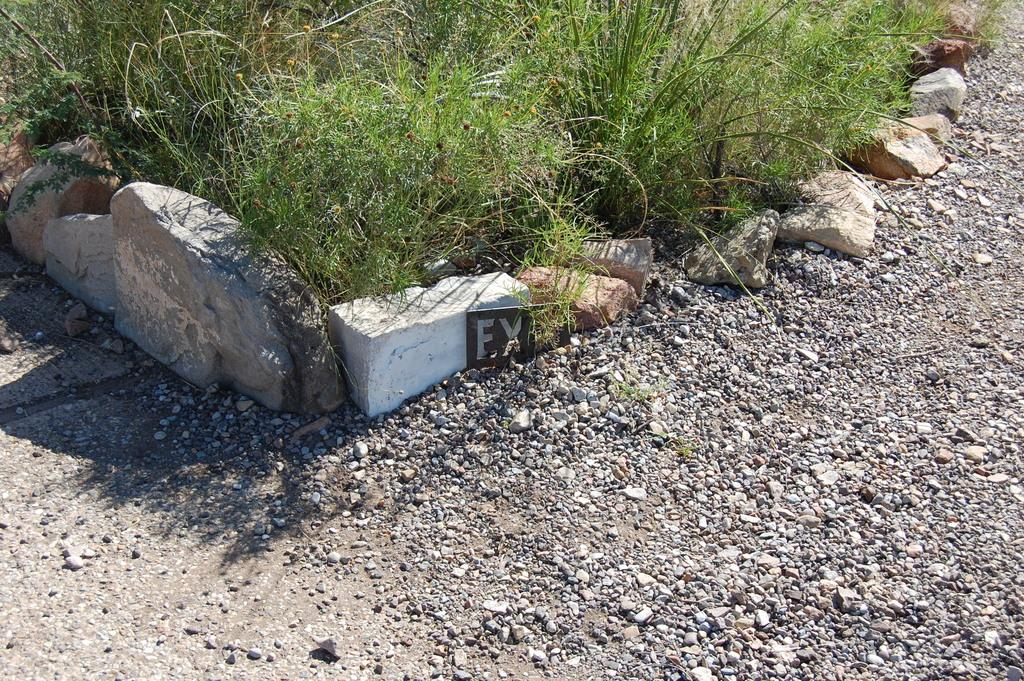What type of surface is visible in the image? There is concrete in the image. What type of barrier can be seen in the image? There is a stone fence in the image. What type of vegetation is present in the image? There is grass in the image. Can you determine the time of day the image was taken? The image was likely taken during the day, as there is sufficient light to see the details clearly. What type of shoe is visible in the image? There is no shoe present in the image. What type of card can be seen in the image? There is no card present in the image. 